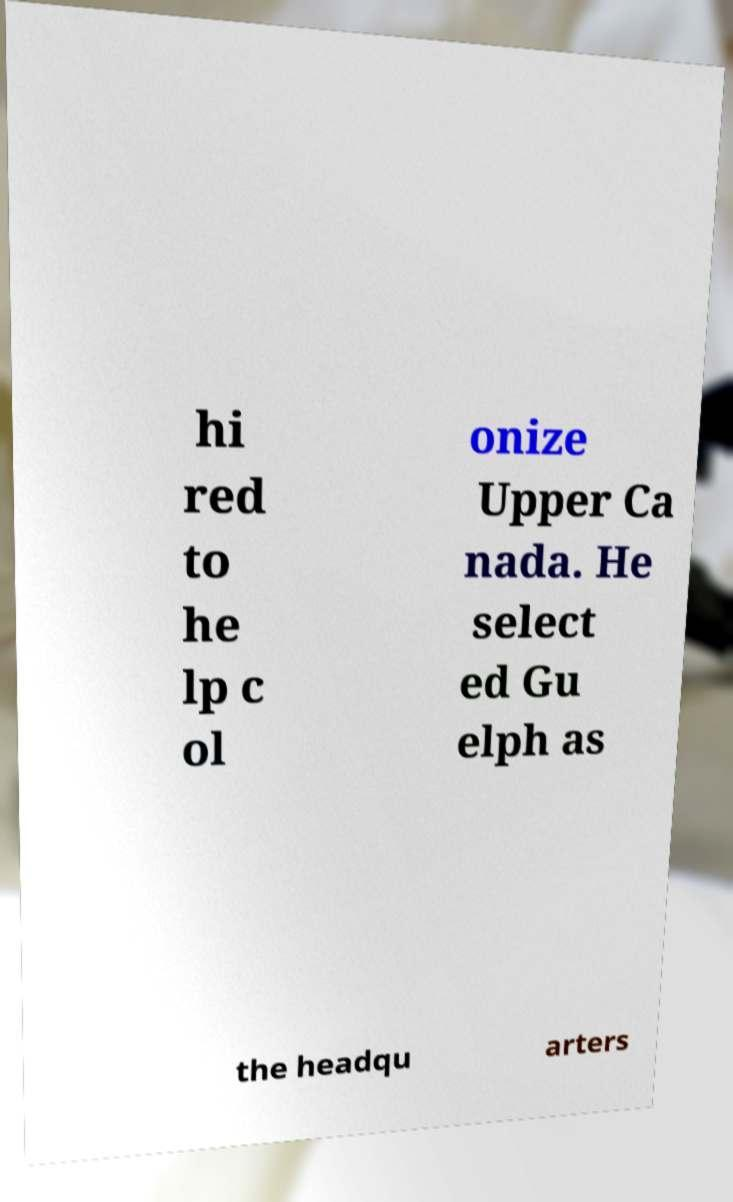What messages or text are displayed in this image? I need them in a readable, typed format. hi red to he lp c ol onize Upper Ca nada. He select ed Gu elph as the headqu arters 